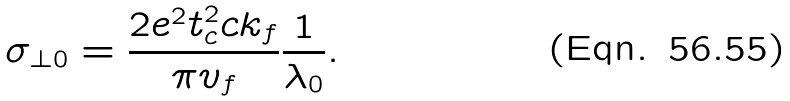<formula> <loc_0><loc_0><loc_500><loc_500>\sigma _ { \perp 0 } = \frac { 2 e ^ { 2 } t _ { c } ^ { 2 } c k _ { f } } { \pi v _ { f } } \frac { 1 } { \lambda _ { 0 } } .</formula> 